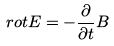Convert formula to latex. <formula><loc_0><loc_0><loc_500><loc_500>r o t E = - \frac { \partial } { \partial t } B</formula> 